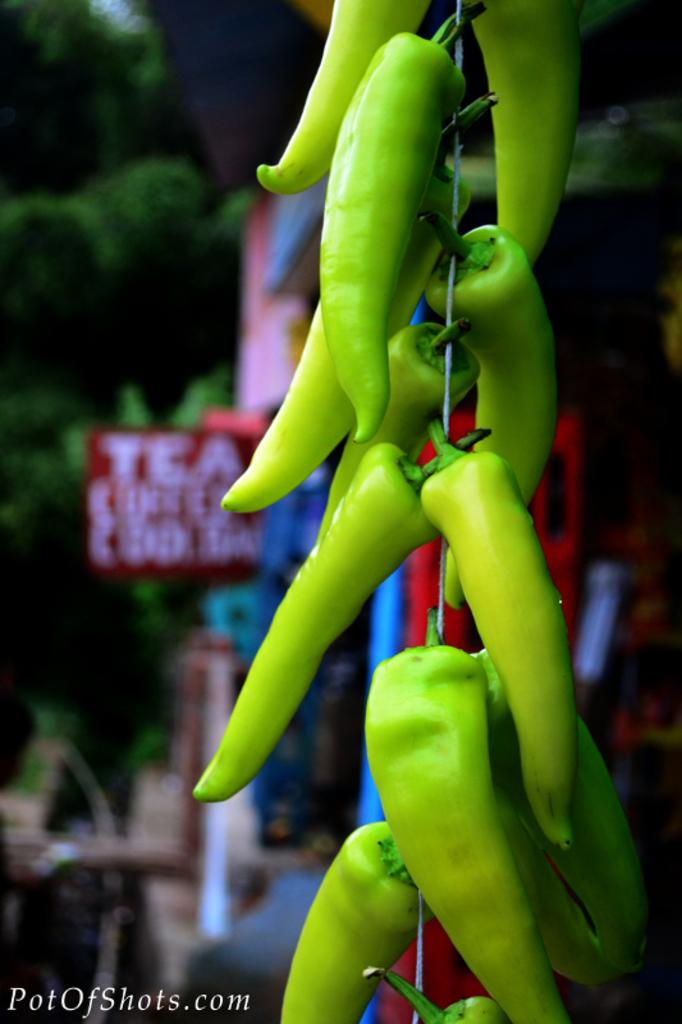What is the main subject of the image? The main subject of the image is green chillies with wire. Can you describe the background of the image? The background of the image is blurry. What can be seen in the background besides the blurry area? There is a red board and trees present in the background of the image. Is there any text visible in the image? Yes, there is text in the bottom left of the image. Can you tell me how many turkeys are visible in the image? There are no turkeys present in the image; it features green chillies with wire. What type of pig can be seen interacting with the chillies in the image? There is no pig present in the image; only green chillies with wire and the mentioned background elements are visible. 